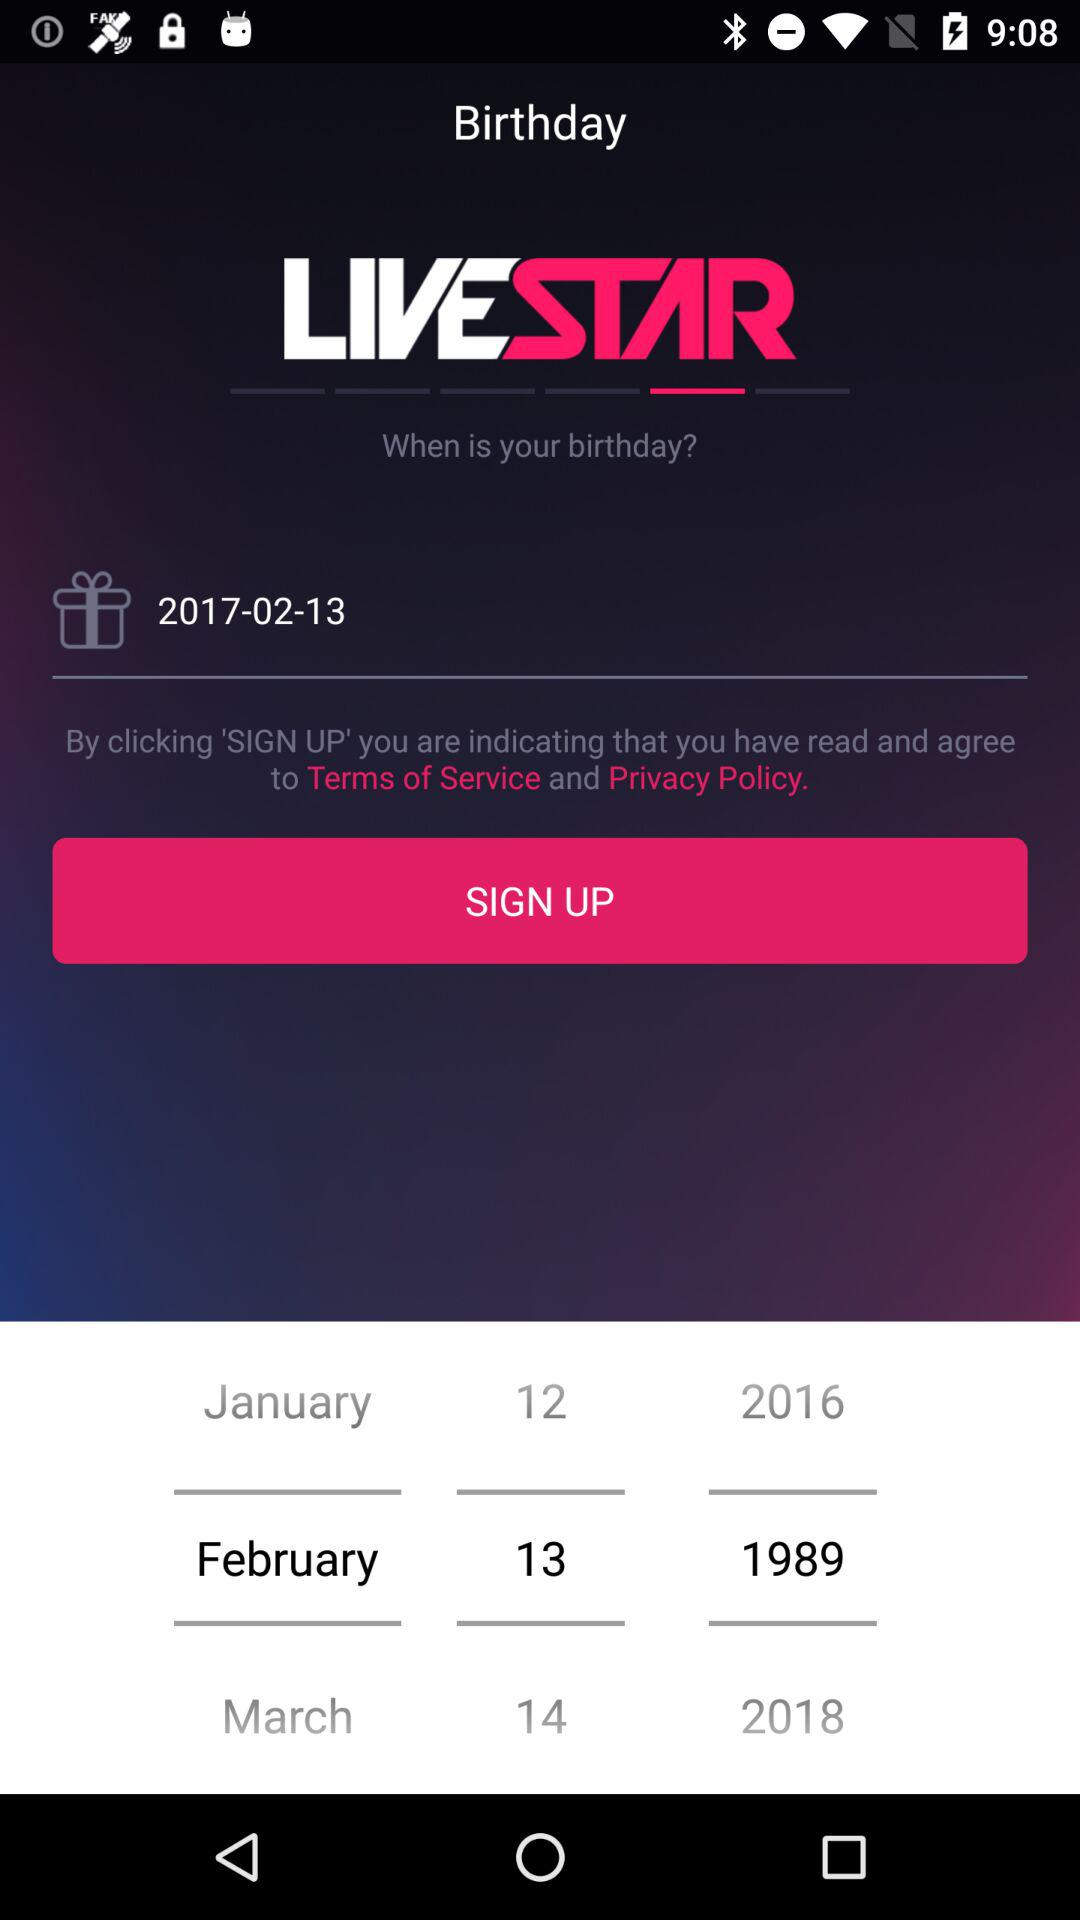What is the app name? The app name is "LIVESTAR". 